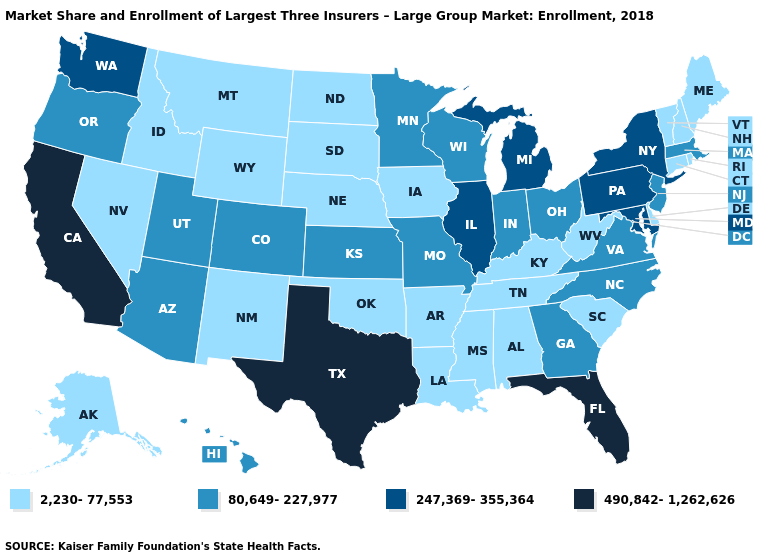Does Missouri have the highest value in the USA?
Short answer required. No. What is the value of Illinois?
Quick response, please. 247,369-355,364. How many symbols are there in the legend?
Give a very brief answer. 4. What is the highest value in the MidWest ?
Concise answer only. 247,369-355,364. What is the value of Virginia?
Answer briefly. 80,649-227,977. What is the lowest value in the MidWest?
Concise answer only. 2,230-77,553. Name the states that have a value in the range 2,230-77,553?
Concise answer only. Alabama, Alaska, Arkansas, Connecticut, Delaware, Idaho, Iowa, Kentucky, Louisiana, Maine, Mississippi, Montana, Nebraska, Nevada, New Hampshire, New Mexico, North Dakota, Oklahoma, Rhode Island, South Carolina, South Dakota, Tennessee, Vermont, West Virginia, Wyoming. Does Wisconsin have a lower value than Colorado?
Short answer required. No. Name the states that have a value in the range 247,369-355,364?
Quick response, please. Illinois, Maryland, Michigan, New York, Pennsylvania, Washington. What is the value of North Carolina?
Write a very short answer. 80,649-227,977. Name the states that have a value in the range 2,230-77,553?
Quick response, please. Alabama, Alaska, Arkansas, Connecticut, Delaware, Idaho, Iowa, Kentucky, Louisiana, Maine, Mississippi, Montana, Nebraska, Nevada, New Hampshire, New Mexico, North Dakota, Oklahoma, Rhode Island, South Carolina, South Dakota, Tennessee, Vermont, West Virginia, Wyoming. Among the states that border Kansas , does Colorado have the lowest value?
Give a very brief answer. No. Does Louisiana have the highest value in the South?
Give a very brief answer. No. What is the highest value in the South ?
Write a very short answer. 490,842-1,262,626. What is the value of South Carolina?
Quick response, please. 2,230-77,553. 